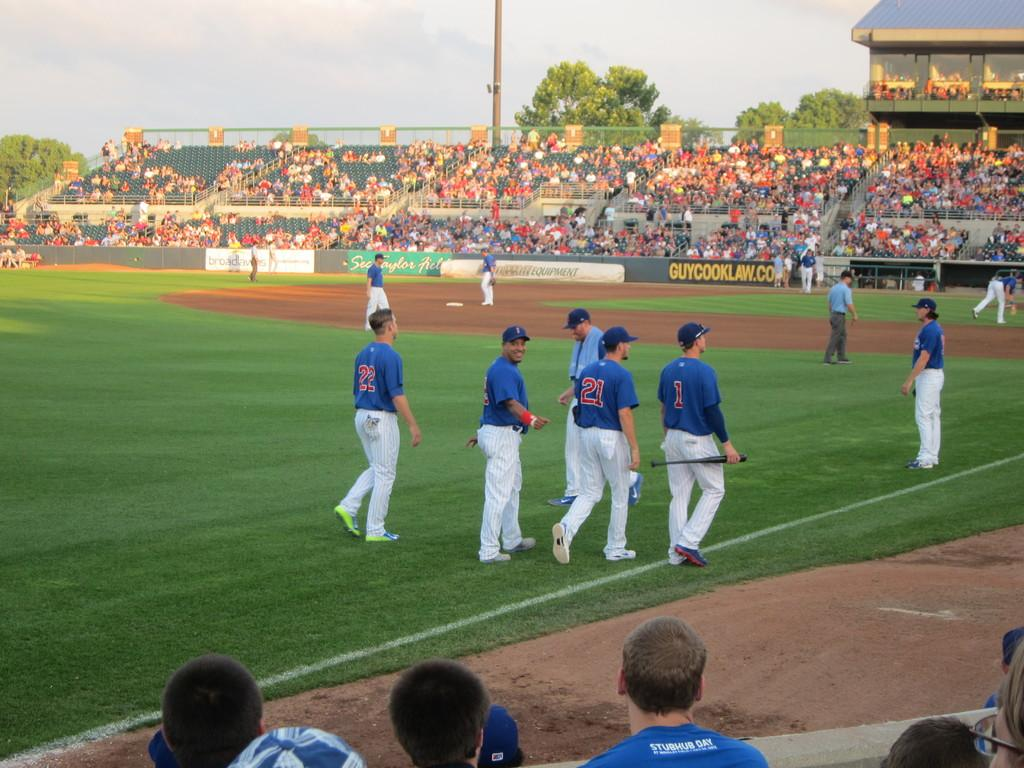Provide a one-sentence caption for the provided image. a banner on the fence at a baseball field for guycooklaw.com. 